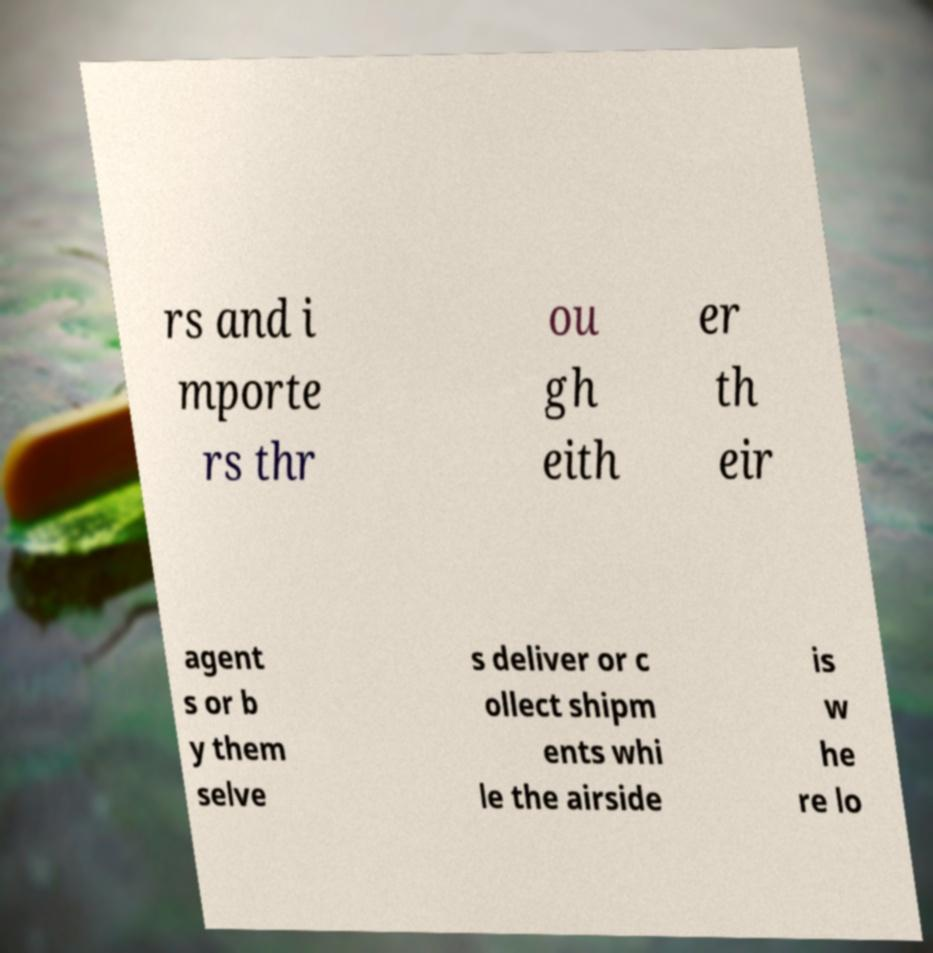Please identify and transcribe the text found in this image. rs and i mporte rs thr ou gh eith er th eir agent s or b y them selve s deliver or c ollect shipm ents whi le the airside is w he re lo 